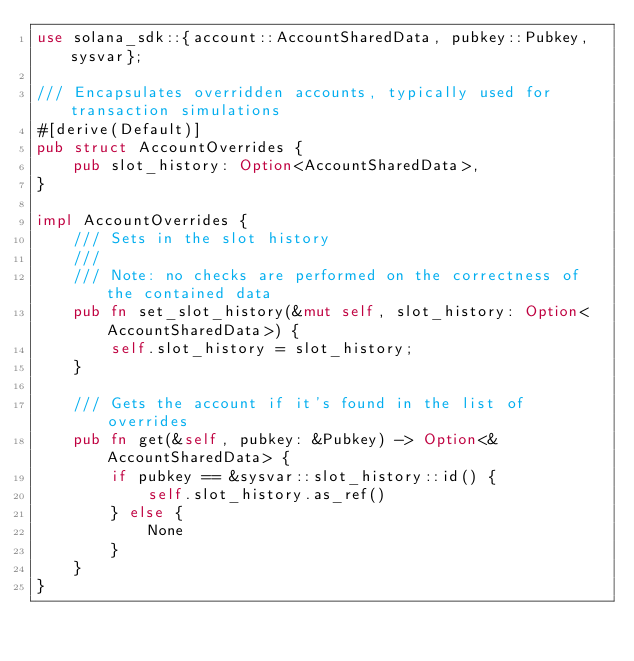<code> <loc_0><loc_0><loc_500><loc_500><_Rust_>use solana_sdk::{account::AccountSharedData, pubkey::Pubkey, sysvar};

/// Encapsulates overridden accounts, typically used for transaction simulations
#[derive(Default)]
pub struct AccountOverrides {
    pub slot_history: Option<AccountSharedData>,
}

impl AccountOverrides {
    /// Sets in the slot history
    ///
    /// Note: no checks are performed on the correctness of the contained data
    pub fn set_slot_history(&mut self, slot_history: Option<AccountSharedData>) {
        self.slot_history = slot_history;
    }

    /// Gets the account if it's found in the list of overrides
    pub fn get(&self, pubkey: &Pubkey) -> Option<&AccountSharedData> {
        if pubkey == &sysvar::slot_history::id() {
            self.slot_history.as_ref()
        } else {
            None
        }
    }
}
</code> 